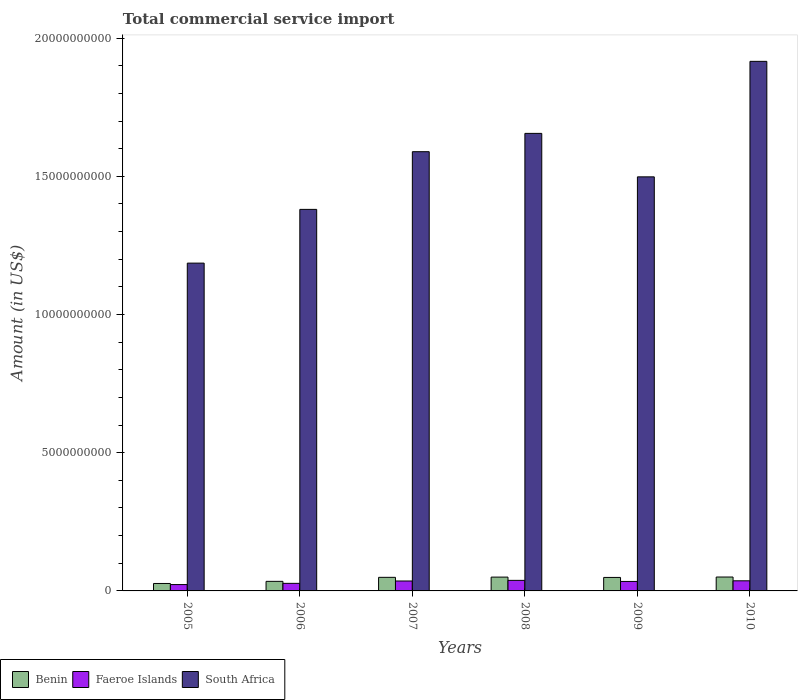How many different coloured bars are there?
Offer a terse response. 3. How many groups of bars are there?
Ensure brevity in your answer.  6. Are the number of bars per tick equal to the number of legend labels?
Give a very brief answer. Yes. How many bars are there on the 6th tick from the left?
Give a very brief answer. 3. What is the label of the 2nd group of bars from the left?
Offer a terse response. 2006. What is the total commercial service import in Benin in 2008?
Offer a very short reply. 5.00e+08. Across all years, what is the maximum total commercial service import in Faeroe Islands?
Keep it short and to the point. 3.82e+08. Across all years, what is the minimum total commercial service import in South Africa?
Make the answer very short. 1.19e+1. What is the total total commercial service import in Faeroe Islands in the graph?
Your answer should be compact. 1.95e+09. What is the difference between the total commercial service import in Benin in 2005 and that in 2008?
Your answer should be very brief. -2.31e+08. What is the difference between the total commercial service import in Faeroe Islands in 2007 and the total commercial service import in Benin in 2010?
Provide a short and direct response. -1.44e+08. What is the average total commercial service import in Faeroe Islands per year?
Offer a terse response. 3.26e+08. In the year 2006, what is the difference between the total commercial service import in Faeroe Islands and total commercial service import in Benin?
Give a very brief answer. -7.19e+07. What is the ratio of the total commercial service import in Benin in 2006 to that in 2008?
Offer a terse response. 0.69. What is the difference between the highest and the second highest total commercial service import in Benin?
Make the answer very short. 2.87e+06. What is the difference between the highest and the lowest total commercial service import in Benin?
Your answer should be compact. 2.34e+08. What does the 2nd bar from the left in 2009 represents?
Provide a short and direct response. Faeroe Islands. What does the 3rd bar from the right in 2010 represents?
Give a very brief answer. Benin. Is it the case that in every year, the sum of the total commercial service import in South Africa and total commercial service import in Faeroe Islands is greater than the total commercial service import in Benin?
Provide a succinct answer. Yes. Are all the bars in the graph horizontal?
Make the answer very short. No. What is the difference between two consecutive major ticks on the Y-axis?
Ensure brevity in your answer.  5.00e+09. Are the values on the major ticks of Y-axis written in scientific E-notation?
Give a very brief answer. No. Where does the legend appear in the graph?
Provide a short and direct response. Bottom left. How many legend labels are there?
Ensure brevity in your answer.  3. What is the title of the graph?
Give a very brief answer. Total commercial service import. What is the label or title of the X-axis?
Ensure brevity in your answer.  Years. What is the label or title of the Y-axis?
Your answer should be compact. Amount (in US$). What is the Amount (in US$) in Benin in 2005?
Keep it short and to the point. 2.69e+08. What is the Amount (in US$) of Faeroe Islands in 2005?
Give a very brief answer. 2.30e+08. What is the Amount (in US$) of South Africa in 2005?
Provide a short and direct response. 1.19e+1. What is the Amount (in US$) of Benin in 2006?
Offer a very short reply. 3.46e+08. What is the Amount (in US$) in Faeroe Islands in 2006?
Your answer should be compact. 2.74e+08. What is the Amount (in US$) of South Africa in 2006?
Make the answer very short. 1.38e+1. What is the Amount (in US$) of Benin in 2007?
Ensure brevity in your answer.  4.91e+08. What is the Amount (in US$) in Faeroe Islands in 2007?
Provide a short and direct response. 3.59e+08. What is the Amount (in US$) in South Africa in 2007?
Provide a short and direct response. 1.59e+1. What is the Amount (in US$) of Benin in 2008?
Your response must be concise. 5.00e+08. What is the Amount (in US$) of Faeroe Islands in 2008?
Make the answer very short. 3.82e+08. What is the Amount (in US$) of South Africa in 2008?
Give a very brief answer. 1.66e+1. What is the Amount (in US$) in Benin in 2009?
Provide a short and direct response. 4.88e+08. What is the Amount (in US$) of Faeroe Islands in 2009?
Provide a short and direct response. 3.43e+08. What is the Amount (in US$) in South Africa in 2009?
Keep it short and to the point. 1.50e+1. What is the Amount (in US$) of Benin in 2010?
Your answer should be very brief. 5.03e+08. What is the Amount (in US$) in Faeroe Islands in 2010?
Make the answer very short. 3.66e+08. What is the Amount (in US$) in South Africa in 2010?
Give a very brief answer. 1.92e+1. Across all years, what is the maximum Amount (in US$) in Benin?
Offer a terse response. 5.03e+08. Across all years, what is the maximum Amount (in US$) of Faeroe Islands?
Your answer should be compact. 3.82e+08. Across all years, what is the maximum Amount (in US$) in South Africa?
Provide a short and direct response. 1.92e+1. Across all years, what is the minimum Amount (in US$) in Benin?
Keep it short and to the point. 2.69e+08. Across all years, what is the minimum Amount (in US$) in Faeroe Islands?
Ensure brevity in your answer.  2.30e+08. Across all years, what is the minimum Amount (in US$) of South Africa?
Offer a terse response. 1.19e+1. What is the total Amount (in US$) in Benin in the graph?
Provide a succinct answer. 2.60e+09. What is the total Amount (in US$) in Faeroe Islands in the graph?
Provide a succinct answer. 1.95e+09. What is the total Amount (in US$) in South Africa in the graph?
Your answer should be compact. 9.22e+1. What is the difference between the Amount (in US$) of Benin in 2005 and that in 2006?
Give a very brief answer. -7.67e+07. What is the difference between the Amount (in US$) in Faeroe Islands in 2005 and that in 2006?
Provide a short and direct response. -4.43e+07. What is the difference between the Amount (in US$) in South Africa in 2005 and that in 2006?
Make the answer very short. -1.94e+09. What is the difference between the Amount (in US$) of Benin in 2005 and that in 2007?
Keep it short and to the point. -2.22e+08. What is the difference between the Amount (in US$) in Faeroe Islands in 2005 and that in 2007?
Your answer should be compact. -1.29e+08. What is the difference between the Amount (in US$) of South Africa in 2005 and that in 2007?
Your answer should be compact. -4.03e+09. What is the difference between the Amount (in US$) of Benin in 2005 and that in 2008?
Give a very brief answer. -2.31e+08. What is the difference between the Amount (in US$) of Faeroe Islands in 2005 and that in 2008?
Keep it short and to the point. -1.52e+08. What is the difference between the Amount (in US$) of South Africa in 2005 and that in 2008?
Your response must be concise. -4.69e+09. What is the difference between the Amount (in US$) in Benin in 2005 and that in 2009?
Keep it short and to the point. -2.19e+08. What is the difference between the Amount (in US$) of Faeroe Islands in 2005 and that in 2009?
Your response must be concise. -1.13e+08. What is the difference between the Amount (in US$) of South Africa in 2005 and that in 2009?
Your answer should be compact. -3.12e+09. What is the difference between the Amount (in US$) in Benin in 2005 and that in 2010?
Provide a succinct answer. -2.34e+08. What is the difference between the Amount (in US$) in Faeroe Islands in 2005 and that in 2010?
Give a very brief answer. -1.36e+08. What is the difference between the Amount (in US$) in South Africa in 2005 and that in 2010?
Provide a succinct answer. -7.30e+09. What is the difference between the Amount (in US$) in Benin in 2006 and that in 2007?
Your answer should be compact. -1.45e+08. What is the difference between the Amount (in US$) in Faeroe Islands in 2006 and that in 2007?
Your answer should be compact. -8.51e+07. What is the difference between the Amount (in US$) of South Africa in 2006 and that in 2007?
Offer a very short reply. -2.09e+09. What is the difference between the Amount (in US$) of Benin in 2006 and that in 2008?
Provide a succinct answer. -1.54e+08. What is the difference between the Amount (in US$) in Faeroe Islands in 2006 and that in 2008?
Offer a very short reply. -1.08e+08. What is the difference between the Amount (in US$) of South Africa in 2006 and that in 2008?
Keep it short and to the point. -2.75e+09. What is the difference between the Amount (in US$) of Benin in 2006 and that in 2009?
Your answer should be very brief. -1.42e+08. What is the difference between the Amount (in US$) of Faeroe Islands in 2006 and that in 2009?
Your answer should be very brief. -6.85e+07. What is the difference between the Amount (in US$) in South Africa in 2006 and that in 2009?
Keep it short and to the point. -1.18e+09. What is the difference between the Amount (in US$) of Benin in 2006 and that in 2010?
Make the answer very short. -1.57e+08. What is the difference between the Amount (in US$) of Faeroe Islands in 2006 and that in 2010?
Your answer should be very brief. -9.20e+07. What is the difference between the Amount (in US$) of South Africa in 2006 and that in 2010?
Offer a very short reply. -5.36e+09. What is the difference between the Amount (in US$) of Benin in 2007 and that in 2008?
Ensure brevity in your answer.  -8.76e+06. What is the difference between the Amount (in US$) of Faeroe Islands in 2007 and that in 2008?
Offer a terse response. -2.27e+07. What is the difference between the Amount (in US$) in South Africa in 2007 and that in 2008?
Your answer should be compact. -6.62e+08. What is the difference between the Amount (in US$) of Benin in 2007 and that in 2009?
Offer a very short reply. 3.08e+06. What is the difference between the Amount (in US$) of Faeroe Islands in 2007 and that in 2009?
Provide a succinct answer. 1.66e+07. What is the difference between the Amount (in US$) in South Africa in 2007 and that in 2009?
Provide a succinct answer. 9.10e+08. What is the difference between the Amount (in US$) in Benin in 2007 and that in 2010?
Your answer should be very brief. -1.16e+07. What is the difference between the Amount (in US$) in Faeroe Islands in 2007 and that in 2010?
Provide a succinct answer. -6.91e+06. What is the difference between the Amount (in US$) in South Africa in 2007 and that in 2010?
Your response must be concise. -3.27e+09. What is the difference between the Amount (in US$) of Benin in 2008 and that in 2009?
Your answer should be compact. 1.18e+07. What is the difference between the Amount (in US$) in Faeroe Islands in 2008 and that in 2009?
Offer a terse response. 3.92e+07. What is the difference between the Amount (in US$) of South Africa in 2008 and that in 2009?
Provide a short and direct response. 1.57e+09. What is the difference between the Amount (in US$) in Benin in 2008 and that in 2010?
Your response must be concise. -2.87e+06. What is the difference between the Amount (in US$) in Faeroe Islands in 2008 and that in 2010?
Offer a terse response. 1.58e+07. What is the difference between the Amount (in US$) of South Africa in 2008 and that in 2010?
Provide a short and direct response. -2.61e+09. What is the difference between the Amount (in US$) in Benin in 2009 and that in 2010?
Provide a succinct answer. -1.47e+07. What is the difference between the Amount (in US$) of Faeroe Islands in 2009 and that in 2010?
Provide a succinct answer. -2.35e+07. What is the difference between the Amount (in US$) in South Africa in 2009 and that in 2010?
Your answer should be very brief. -4.18e+09. What is the difference between the Amount (in US$) of Benin in 2005 and the Amount (in US$) of Faeroe Islands in 2006?
Give a very brief answer. -4.80e+06. What is the difference between the Amount (in US$) of Benin in 2005 and the Amount (in US$) of South Africa in 2006?
Your answer should be very brief. -1.35e+1. What is the difference between the Amount (in US$) of Faeroe Islands in 2005 and the Amount (in US$) of South Africa in 2006?
Make the answer very short. -1.36e+1. What is the difference between the Amount (in US$) of Benin in 2005 and the Amount (in US$) of Faeroe Islands in 2007?
Ensure brevity in your answer.  -8.99e+07. What is the difference between the Amount (in US$) of Benin in 2005 and the Amount (in US$) of South Africa in 2007?
Offer a very short reply. -1.56e+1. What is the difference between the Amount (in US$) of Faeroe Islands in 2005 and the Amount (in US$) of South Africa in 2007?
Provide a short and direct response. -1.57e+1. What is the difference between the Amount (in US$) of Benin in 2005 and the Amount (in US$) of Faeroe Islands in 2008?
Your response must be concise. -1.13e+08. What is the difference between the Amount (in US$) in Benin in 2005 and the Amount (in US$) in South Africa in 2008?
Offer a very short reply. -1.63e+1. What is the difference between the Amount (in US$) in Faeroe Islands in 2005 and the Amount (in US$) in South Africa in 2008?
Provide a succinct answer. -1.63e+1. What is the difference between the Amount (in US$) of Benin in 2005 and the Amount (in US$) of Faeroe Islands in 2009?
Offer a very short reply. -7.33e+07. What is the difference between the Amount (in US$) in Benin in 2005 and the Amount (in US$) in South Africa in 2009?
Offer a terse response. -1.47e+1. What is the difference between the Amount (in US$) in Faeroe Islands in 2005 and the Amount (in US$) in South Africa in 2009?
Offer a terse response. -1.48e+1. What is the difference between the Amount (in US$) of Benin in 2005 and the Amount (in US$) of Faeroe Islands in 2010?
Give a very brief answer. -9.68e+07. What is the difference between the Amount (in US$) of Benin in 2005 and the Amount (in US$) of South Africa in 2010?
Ensure brevity in your answer.  -1.89e+1. What is the difference between the Amount (in US$) in Faeroe Islands in 2005 and the Amount (in US$) in South Africa in 2010?
Make the answer very short. -1.89e+1. What is the difference between the Amount (in US$) in Benin in 2006 and the Amount (in US$) in Faeroe Islands in 2007?
Give a very brief answer. -1.33e+07. What is the difference between the Amount (in US$) in Benin in 2006 and the Amount (in US$) in South Africa in 2007?
Your answer should be compact. -1.55e+1. What is the difference between the Amount (in US$) in Faeroe Islands in 2006 and the Amount (in US$) in South Africa in 2007?
Your response must be concise. -1.56e+1. What is the difference between the Amount (in US$) of Benin in 2006 and the Amount (in US$) of Faeroe Islands in 2008?
Keep it short and to the point. -3.59e+07. What is the difference between the Amount (in US$) of Benin in 2006 and the Amount (in US$) of South Africa in 2008?
Provide a succinct answer. -1.62e+1. What is the difference between the Amount (in US$) of Faeroe Islands in 2006 and the Amount (in US$) of South Africa in 2008?
Ensure brevity in your answer.  -1.63e+1. What is the difference between the Amount (in US$) in Benin in 2006 and the Amount (in US$) in Faeroe Islands in 2009?
Your answer should be very brief. 3.31e+06. What is the difference between the Amount (in US$) of Benin in 2006 and the Amount (in US$) of South Africa in 2009?
Give a very brief answer. -1.46e+1. What is the difference between the Amount (in US$) of Faeroe Islands in 2006 and the Amount (in US$) of South Africa in 2009?
Your answer should be compact. -1.47e+1. What is the difference between the Amount (in US$) in Benin in 2006 and the Amount (in US$) in Faeroe Islands in 2010?
Make the answer very short. -2.02e+07. What is the difference between the Amount (in US$) in Benin in 2006 and the Amount (in US$) in South Africa in 2010?
Provide a short and direct response. -1.88e+1. What is the difference between the Amount (in US$) in Faeroe Islands in 2006 and the Amount (in US$) in South Africa in 2010?
Make the answer very short. -1.89e+1. What is the difference between the Amount (in US$) in Benin in 2007 and the Amount (in US$) in Faeroe Islands in 2008?
Make the answer very short. 1.09e+08. What is the difference between the Amount (in US$) of Benin in 2007 and the Amount (in US$) of South Africa in 2008?
Offer a very short reply. -1.61e+1. What is the difference between the Amount (in US$) of Faeroe Islands in 2007 and the Amount (in US$) of South Africa in 2008?
Provide a succinct answer. -1.62e+1. What is the difference between the Amount (in US$) of Benin in 2007 and the Amount (in US$) of Faeroe Islands in 2009?
Offer a very short reply. 1.49e+08. What is the difference between the Amount (in US$) of Benin in 2007 and the Amount (in US$) of South Africa in 2009?
Provide a succinct answer. -1.45e+1. What is the difference between the Amount (in US$) in Faeroe Islands in 2007 and the Amount (in US$) in South Africa in 2009?
Your answer should be very brief. -1.46e+1. What is the difference between the Amount (in US$) in Benin in 2007 and the Amount (in US$) in Faeroe Islands in 2010?
Give a very brief answer. 1.25e+08. What is the difference between the Amount (in US$) of Benin in 2007 and the Amount (in US$) of South Africa in 2010?
Offer a terse response. -1.87e+1. What is the difference between the Amount (in US$) in Faeroe Islands in 2007 and the Amount (in US$) in South Africa in 2010?
Your response must be concise. -1.88e+1. What is the difference between the Amount (in US$) of Benin in 2008 and the Amount (in US$) of Faeroe Islands in 2009?
Give a very brief answer. 1.57e+08. What is the difference between the Amount (in US$) of Benin in 2008 and the Amount (in US$) of South Africa in 2009?
Your response must be concise. -1.45e+1. What is the difference between the Amount (in US$) in Faeroe Islands in 2008 and the Amount (in US$) in South Africa in 2009?
Your response must be concise. -1.46e+1. What is the difference between the Amount (in US$) of Benin in 2008 and the Amount (in US$) of Faeroe Islands in 2010?
Ensure brevity in your answer.  1.34e+08. What is the difference between the Amount (in US$) of Benin in 2008 and the Amount (in US$) of South Africa in 2010?
Your response must be concise. -1.87e+1. What is the difference between the Amount (in US$) in Faeroe Islands in 2008 and the Amount (in US$) in South Africa in 2010?
Keep it short and to the point. -1.88e+1. What is the difference between the Amount (in US$) of Benin in 2009 and the Amount (in US$) of Faeroe Islands in 2010?
Make the answer very short. 1.22e+08. What is the difference between the Amount (in US$) in Benin in 2009 and the Amount (in US$) in South Africa in 2010?
Ensure brevity in your answer.  -1.87e+1. What is the difference between the Amount (in US$) in Faeroe Islands in 2009 and the Amount (in US$) in South Africa in 2010?
Make the answer very short. -1.88e+1. What is the average Amount (in US$) of Benin per year?
Ensure brevity in your answer.  4.33e+08. What is the average Amount (in US$) in Faeroe Islands per year?
Your answer should be very brief. 3.26e+08. What is the average Amount (in US$) in South Africa per year?
Offer a very short reply. 1.54e+1. In the year 2005, what is the difference between the Amount (in US$) in Benin and Amount (in US$) in Faeroe Islands?
Give a very brief answer. 3.95e+07. In the year 2005, what is the difference between the Amount (in US$) in Benin and Amount (in US$) in South Africa?
Your answer should be compact. -1.16e+1. In the year 2005, what is the difference between the Amount (in US$) of Faeroe Islands and Amount (in US$) of South Africa?
Provide a short and direct response. -1.16e+1. In the year 2006, what is the difference between the Amount (in US$) in Benin and Amount (in US$) in Faeroe Islands?
Your response must be concise. 7.19e+07. In the year 2006, what is the difference between the Amount (in US$) in Benin and Amount (in US$) in South Africa?
Offer a very short reply. -1.35e+1. In the year 2006, what is the difference between the Amount (in US$) of Faeroe Islands and Amount (in US$) of South Africa?
Give a very brief answer. -1.35e+1. In the year 2007, what is the difference between the Amount (in US$) of Benin and Amount (in US$) of Faeroe Islands?
Your answer should be compact. 1.32e+08. In the year 2007, what is the difference between the Amount (in US$) in Benin and Amount (in US$) in South Africa?
Provide a succinct answer. -1.54e+1. In the year 2007, what is the difference between the Amount (in US$) of Faeroe Islands and Amount (in US$) of South Africa?
Provide a succinct answer. -1.55e+1. In the year 2008, what is the difference between the Amount (in US$) in Benin and Amount (in US$) in Faeroe Islands?
Make the answer very short. 1.18e+08. In the year 2008, what is the difference between the Amount (in US$) of Benin and Amount (in US$) of South Africa?
Provide a short and direct response. -1.61e+1. In the year 2008, what is the difference between the Amount (in US$) of Faeroe Islands and Amount (in US$) of South Africa?
Keep it short and to the point. -1.62e+1. In the year 2009, what is the difference between the Amount (in US$) of Benin and Amount (in US$) of Faeroe Islands?
Give a very brief answer. 1.46e+08. In the year 2009, what is the difference between the Amount (in US$) of Benin and Amount (in US$) of South Africa?
Provide a succinct answer. -1.45e+1. In the year 2009, what is the difference between the Amount (in US$) of Faeroe Islands and Amount (in US$) of South Africa?
Offer a terse response. -1.46e+1. In the year 2010, what is the difference between the Amount (in US$) in Benin and Amount (in US$) in Faeroe Islands?
Offer a terse response. 1.37e+08. In the year 2010, what is the difference between the Amount (in US$) in Benin and Amount (in US$) in South Africa?
Make the answer very short. -1.87e+1. In the year 2010, what is the difference between the Amount (in US$) in Faeroe Islands and Amount (in US$) in South Africa?
Ensure brevity in your answer.  -1.88e+1. What is the ratio of the Amount (in US$) in Benin in 2005 to that in 2006?
Your response must be concise. 0.78. What is the ratio of the Amount (in US$) in Faeroe Islands in 2005 to that in 2006?
Make the answer very short. 0.84. What is the ratio of the Amount (in US$) of South Africa in 2005 to that in 2006?
Provide a succinct answer. 0.86. What is the ratio of the Amount (in US$) of Benin in 2005 to that in 2007?
Provide a succinct answer. 0.55. What is the ratio of the Amount (in US$) in Faeroe Islands in 2005 to that in 2007?
Provide a short and direct response. 0.64. What is the ratio of the Amount (in US$) in South Africa in 2005 to that in 2007?
Ensure brevity in your answer.  0.75. What is the ratio of the Amount (in US$) in Benin in 2005 to that in 2008?
Your answer should be very brief. 0.54. What is the ratio of the Amount (in US$) of Faeroe Islands in 2005 to that in 2008?
Keep it short and to the point. 0.6. What is the ratio of the Amount (in US$) in South Africa in 2005 to that in 2008?
Your response must be concise. 0.72. What is the ratio of the Amount (in US$) in Benin in 2005 to that in 2009?
Provide a succinct answer. 0.55. What is the ratio of the Amount (in US$) in Faeroe Islands in 2005 to that in 2009?
Your response must be concise. 0.67. What is the ratio of the Amount (in US$) of South Africa in 2005 to that in 2009?
Ensure brevity in your answer.  0.79. What is the ratio of the Amount (in US$) of Benin in 2005 to that in 2010?
Offer a terse response. 0.54. What is the ratio of the Amount (in US$) in Faeroe Islands in 2005 to that in 2010?
Your answer should be very brief. 0.63. What is the ratio of the Amount (in US$) of South Africa in 2005 to that in 2010?
Ensure brevity in your answer.  0.62. What is the ratio of the Amount (in US$) in Benin in 2006 to that in 2007?
Your answer should be very brief. 0.7. What is the ratio of the Amount (in US$) in Faeroe Islands in 2006 to that in 2007?
Make the answer very short. 0.76. What is the ratio of the Amount (in US$) in South Africa in 2006 to that in 2007?
Give a very brief answer. 0.87. What is the ratio of the Amount (in US$) of Benin in 2006 to that in 2008?
Offer a terse response. 0.69. What is the ratio of the Amount (in US$) in Faeroe Islands in 2006 to that in 2008?
Provide a short and direct response. 0.72. What is the ratio of the Amount (in US$) in South Africa in 2006 to that in 2008?
Your answer should be compact. 0.83. What is the ratio of the Amount (in US$) in Benin in 2006 to that in 2009?
Ensure brevity in your answer.  0.71. What is the ratio of the Amount (in US$) in Faeroe Islands in 2006 to that in 2009?
Make the answer very short. 0.8. What is the ratio of the Amount (in US$) of South Africa in 2006 to that in 2009?
Provide a short and direct response. 0.92. What is the ratio of the Amount (in US$) of Benin in 2006 to that in 2010?
Offer a very short reply. 0.69. What is the ratio of the Amount (in US$) of Faeroe Islands in 2006 to that in 2010?
Your response must be concise. 0.75. What is the ratio of the Amount (in US$) of South Africa in 2006 to that in 2010?
Offer a terse response. 0.72. What is the ratio of the Amount (in US$) of Benin in 2007 to that in 2008?
Your answer should be very brief. 0.98. What is the ratio of the Amount (in US$) of Faeroe Islands in 2007 to that in 2008?
Keep it short and to the point. 0.94. What is the ratio of the Amount (in US$) in South Africa in 2007 to that in 2008?
Provide a succinct answer. 0.96. What is the ratio of the Amount (in US$) in Benin in 2007 to that in 2009?
Make the answer very short. 1.01. What is the ratio of the Amount (in US$) of Faeroe Islands in 2007 to that in 2009?
Offer a terse response. 1.05. What is the ratio of the Amount (in US$) in South Africa in 2007 to that in 2009?
Offer a very short reply. 1.06. What is the ratio of the Amount (in US$) in Benin in 2007 to that in 2010?
Give a very brief answer. 0.98. What is the ratio of the Amount (in US$) of Faeroe Islands in 2007 to that in 2010?
Provide a succinct answer. 0.98. What is the ratio of the Amount (in US$) of South Africa in 2007 to that in 2010?
Provide a short and direct response. 0.83. What is the ratio of the Amount (in US$) of Benin in 2008 to that in 2009?
Provide a short and direct response. 1.02. What is the ratio of the Amount (in US$) of Faeroe Islands in 2008 to that in 2009?
Your answer should be compact. 1.11. What is the ratio of the Amount (in US$) in South Africa in 2008 to that in 2009?
Ensure brevity in your answer.  1.1. What is the ratio of the Amount (in US$) in Benin in 2008 to that in 2010?
Offer a terse response. 0.99. What is the ratio of the Amount (in US$) in Faeroe Islands in 2008 to that in 2010?
Your response must be concise. 1.04. What is the ratio of the Amount (in US$) in South Africa in 2008 to that in 2010?
Your answer should be compact. 0.86. What is the ratio of the Amount (in US$) of Benin in 2009 to that in 2010?
Keep it short and to the point. 0.97. What is the ratio of the Amount (in US$) in Faeroe Islands in 2009 to that in 2010?
Make the answer very short. 0.94. What is the ratio of the Amount (in US$) of South Africa in 2009 to that in 2010?
Provide a short and direct response. 0.78. What is the difference between the highest and the second highest Amount (in US$) in Benin?
Ensure brevity in your answer.  2.87e+06. What is the difference between the highest and the second highest Amount (in US$) in Faeroe Islands?
Ensure brevity in your answer.  1.58e+07. What is the difference between the highest and the second highest Amount (in US$) in South Africa?
Your answer should be compact. 2.61e+09. What is the difference between the highest and the lowest Amount (in US$) of Benin?
Your response must be concise. 2.34e+08. What is the difference between the highest and the lowest Amount (in US$) in Faeroe Islands?
Offer a terse response. 1.52e+08. What is the difference between the highest and the lowest Amount (in US$) of South Africa?
Offer a very short reply. 7.30e+09. 